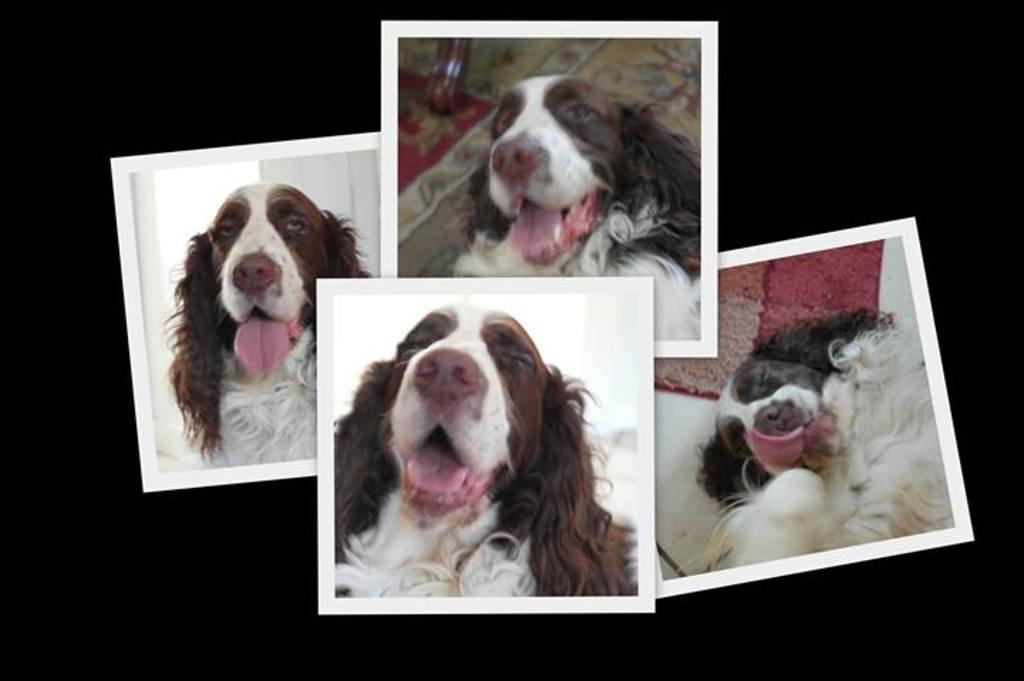Please provide a concise description of this image. In this picture we can see there four photos of a dog in different angles. Behind the photos there is a dark background. 